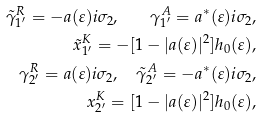Convert formula to latex. <formula><loc_0><loc_0><loc_500><loc_500>\tilde { \gamma } _ { 1 ^ { \prime } } ^ { R } = - a ( \varepsilon ) i \sigma _ { 2 } , \quad \gamma _ { 1 ^ { \prime } } ^ { A } = a ^ { * } ( \varepsilon ) i \sigma _ { 2 } , \\ \tilde { x } _ { 1 ^ { \prime } } ^ { K } = - [ 1 - | a ( \varepsilon ) | ^ { 2 } ] h _ { 0 } ( \varepsilon ) , \\ \gamma _ { 2 ^ { \prime } } ^ { R } = a ( \varepsilon ) i \sigma _ { 2 } , \quad \tilde { \gamma } _ { 2 ^ { \prime } } ^ { A } = - a ^ { * } ( \varepsilon ) i \sigma _ { 2 } , \\ x _ { 2 ^ { \prime } } ^ { K } = [ 1 - | a ( \varepsilon ) | ^ { 2 } ] h _ { 0 } ( \varepsilon ) ,</formula> 